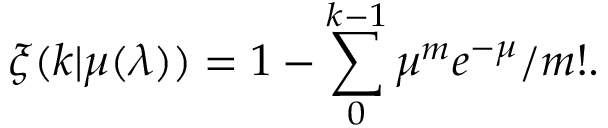<formula> <loc_0><loc_0><loc_500><loc_500>\xi ( k | \mu ( \lambda ) ) = 1 - \sum _ { 0 } ^ { k - 1 } \mu ^ { m } e ^ { - \mu } / m ! .</formula> 